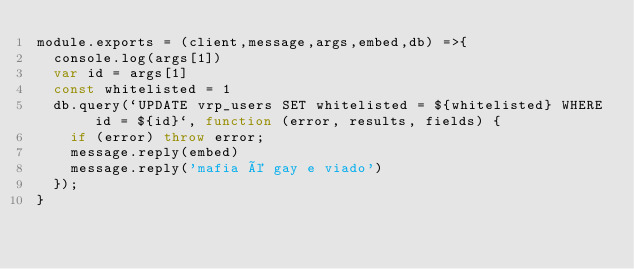<code> <loc_0><loc_0><loc_500><loc_500><_JavaScript_>module.exports = (client,message,args,embed,db) =>{
  console.log(args[1])
  var id = args[1]
  const whitelisted = 1
  db.query(`UPDATE vrp_users SET whitelisted = ${whitelisted} WHERE id = ${id}`, function (error, results, fields) {
    if (error) throw error;
    message.reply(embed) 
    message.reply('mafia é gay e viado')
  });
}</code> 